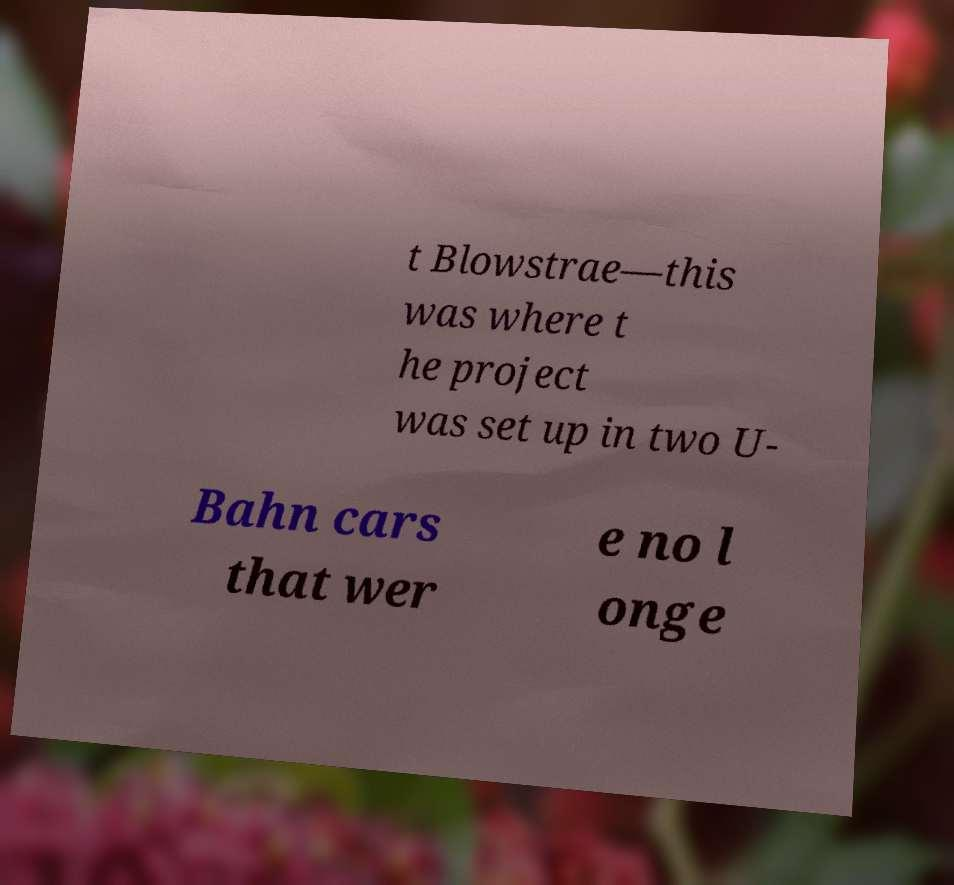Could you assist in decoding the text presented in this image and type it out clearly? t Blowstrae—this was where t he project was set up in two U- Bahn cars that wer e no l onge 